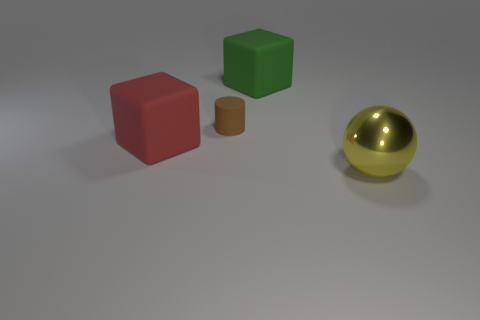How many big rubber things are both behind the large red rubber cube and on the left side of the brown object?
Offer a very short reply. 0. There is a small object; are there any brown cylinders on the right side of it?
Make the answer very short. No. Is the shape of the matte object that is on the right side of the cylinder the same as the big thing left of the big green rubber thing?
Offer a terse response. Yes. How many objects are rubber cylinders or objects that are to the right of the small thing?
Ensure brevity in your answer.  3. What number of other objects are the same shape as the large red matte object?
Offer a very short reply. 1. Is the material of the object in front of the big red object the same as the tiny brown cylinder?
Provide a succinct answer. No. What number of objects are either brown shiny cubes or tiny brown rubber cylinders?
Keep it short and to the point. 1. What is the size of the other rubber object that is the same shape as the red matte thing?
Your answer should be very brief. Large. The red rubber block has what size?
Your answer should be very brief. Large. Are there more tiny rubber cylinders that are behind the red thing than gray matte objects?
Your answer should be very brief. Yes. 